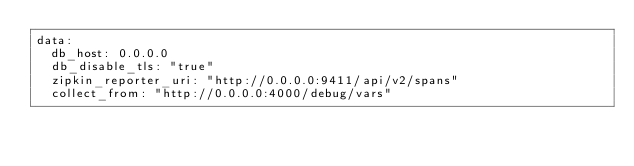<code> <loc_0><loc_0><loc_500><loc_500><_YAML_>data:
  db_host: 0.0.0.0
  db_disable_tls: "true"
  zipkin_reporter_uri: "http://0.0.0.0:9411/api/v2/spans"
  collect_from: "http://0.0.0.0:4000/debug/vars"</code> 